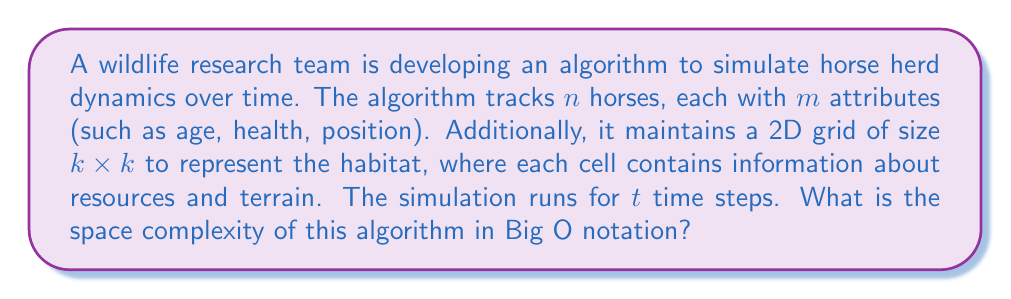Help me with this question. To determine the space complexity, we need to consider all the data structures used in the algorithm:

1. Horse data:
   - There are $n$ horses
   - Each horse has $m$ attributes
   - Total space for horse data: $O(n \cdot m)$

2. Habitat grid:
   - The grid is of size $k \times k$
   - Each cell contains a constant amount of information
   - Total space for habitat grid: $O(k^2)$

3. Time steps:
   - The number of time steps $t$ doesn't affect the space complexity directly, as we typically only need to store the current state of the simulation

4. Additional variables:
   - We may need some additional variables for calculations, but these are typically constant in number and don't depend on $n$, $m$, or $k$

Combining these factors, the total space complexity is:

$$O(n \cdot m + k^2)$$

This represents the sum of the space needed for horse data and the habitat grid. We don't include any terms related to $t$ because the simulation typically only stores the current state, not the entire history.

In the context of algorithm analysis, we usually express the space complexity in terms of the input size. In this case, we can consider $n$ (number of horses) as the primary input size. The values of $m$ and $k$ are typically considered as parameters of the problem rather than input size.

If we assume that $m$ and $k$ are constants or grow much slower than $n$, we can simplify the space complexity to $O(n)$. However, if $k$ grows significantly with $n$ (e.g., if larger herds require proportionally larger habitats), we should keep the $k^2$ term.
Answer: The space complexity of the algorithm is $O(n \cdot m + k^2)$, where $n$ is the number of horses, $m$ is the number of attributes per horse, and $k$ is the side length of the square habitat grid. 